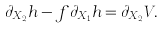<formula> <loc_0><loc_0><loc_500><loc_500>\partial _ { X _ { 2 } } h - f \partial _ { X _ { 1 } } h = \partial _ { X _ { 2 } } V .</formula> 